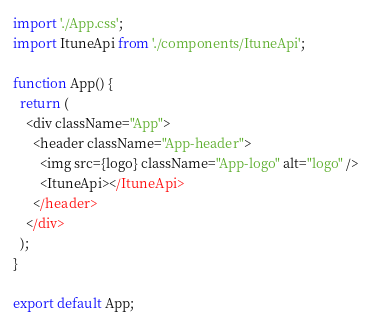Convert code to text. <code><loc_0><loc_0><loc_500><loc_500><_JavaScript_>import './App.css';
import ItuneApi from './components/ItuneApi';

function App() {
  return (
    <div className="App">
      <header className="App-header">
        <img src={logo} className="App-logo" alt="logo" />
        <ItuneApi></ItuneApi>
      </header>
    </div>
  );
}

export default App;
</code> 